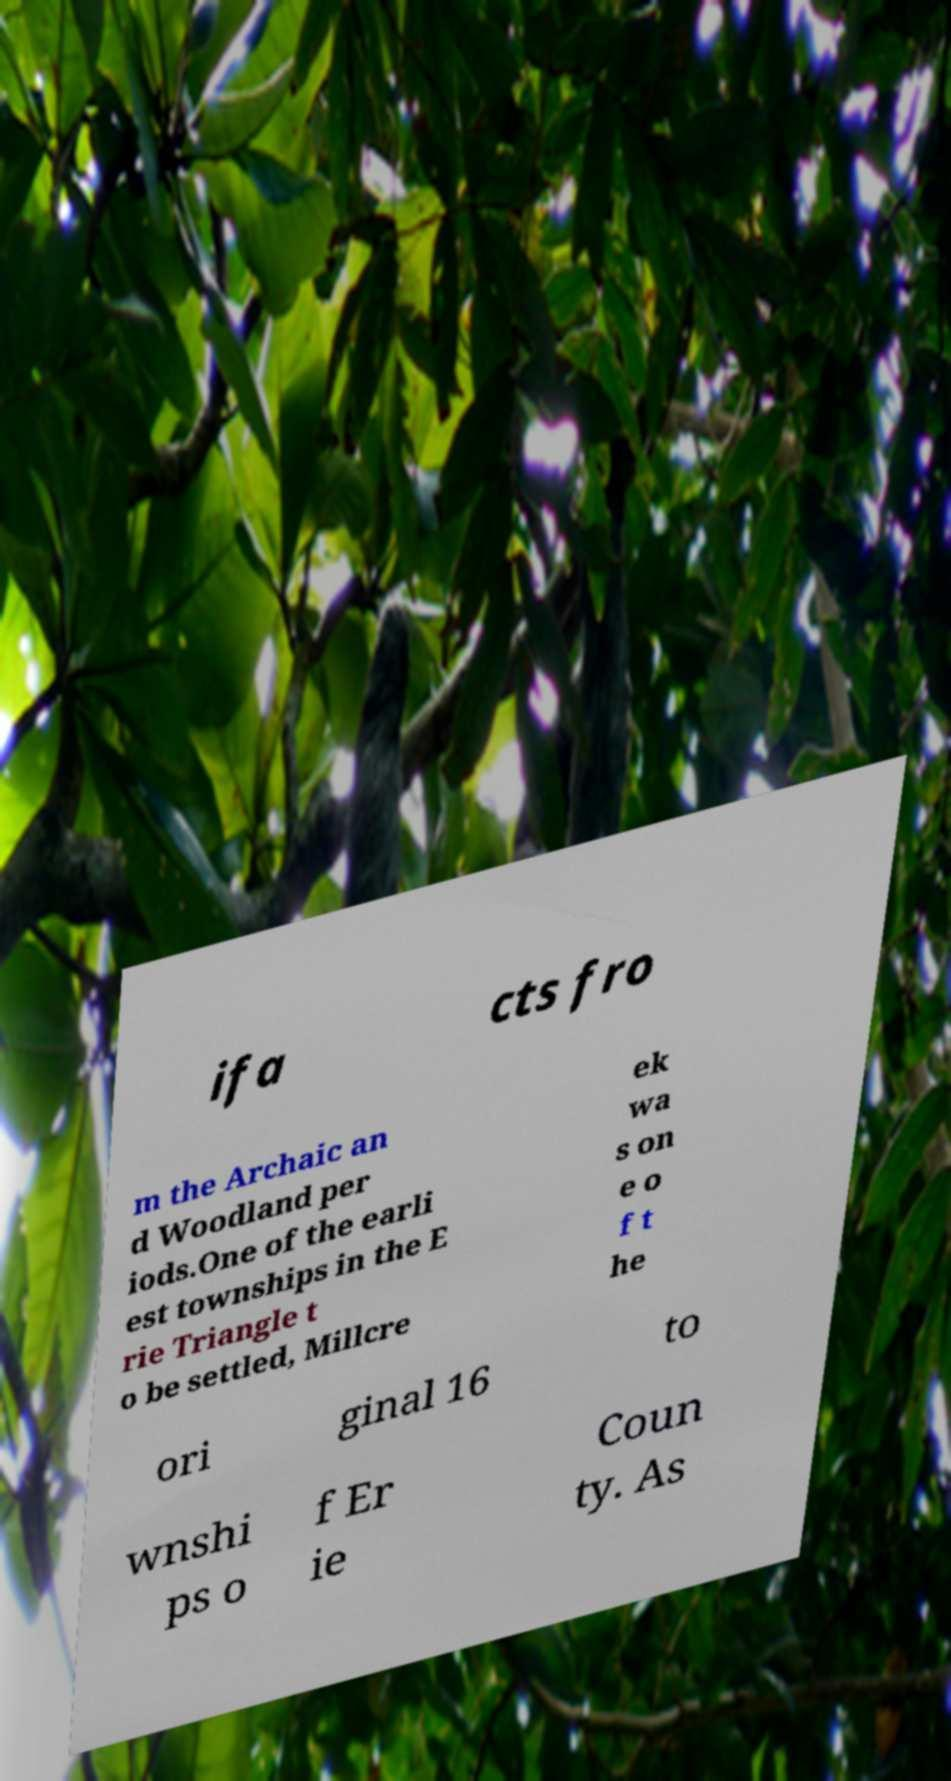I need the written content from this picture converted into text. Can you do that? ifa cts fro m the Archaic an d Woodland per iods.One of the earli est townships in the E rie Triangle t o be settled, Millcre ek wa s on e o f t he ori ginal 16 to wnshi ps o f Er ie Coun ty. As 